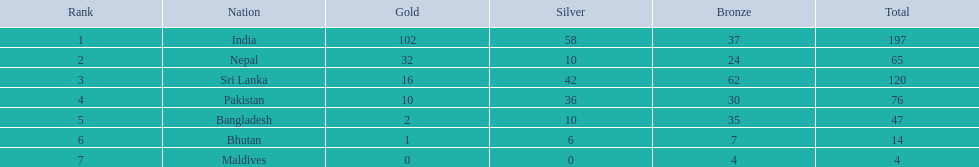What is the total number of gold medals acquired by the teams? 102, 32, 16, 10, 2, 1, 0. Which nation did not secure any gold medals? Maldives. 